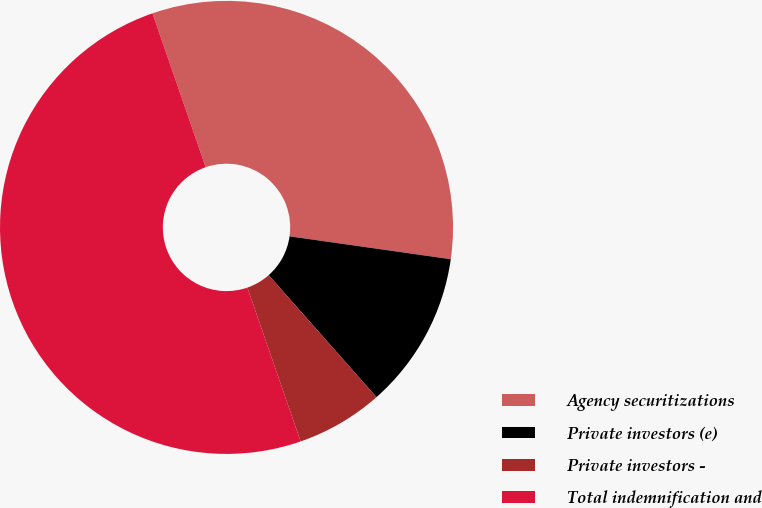Convert chart. <chart><loc_0><loc_0><loc_500><loc_500><pie_chart><fcel>Agency securitizations<fcel>Private investors (e)<fcel>Private investors -<fcel>Total indemnification and<nl><fcel>32.54%<fcel>11.24%<fcel>6.21%<fcel>50.0%<nl></chart> 